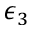Convert formula to latex. <formula><loc_0><loc_0><loc_500><loc_500>\epsilon _ { 3 }</formula> 